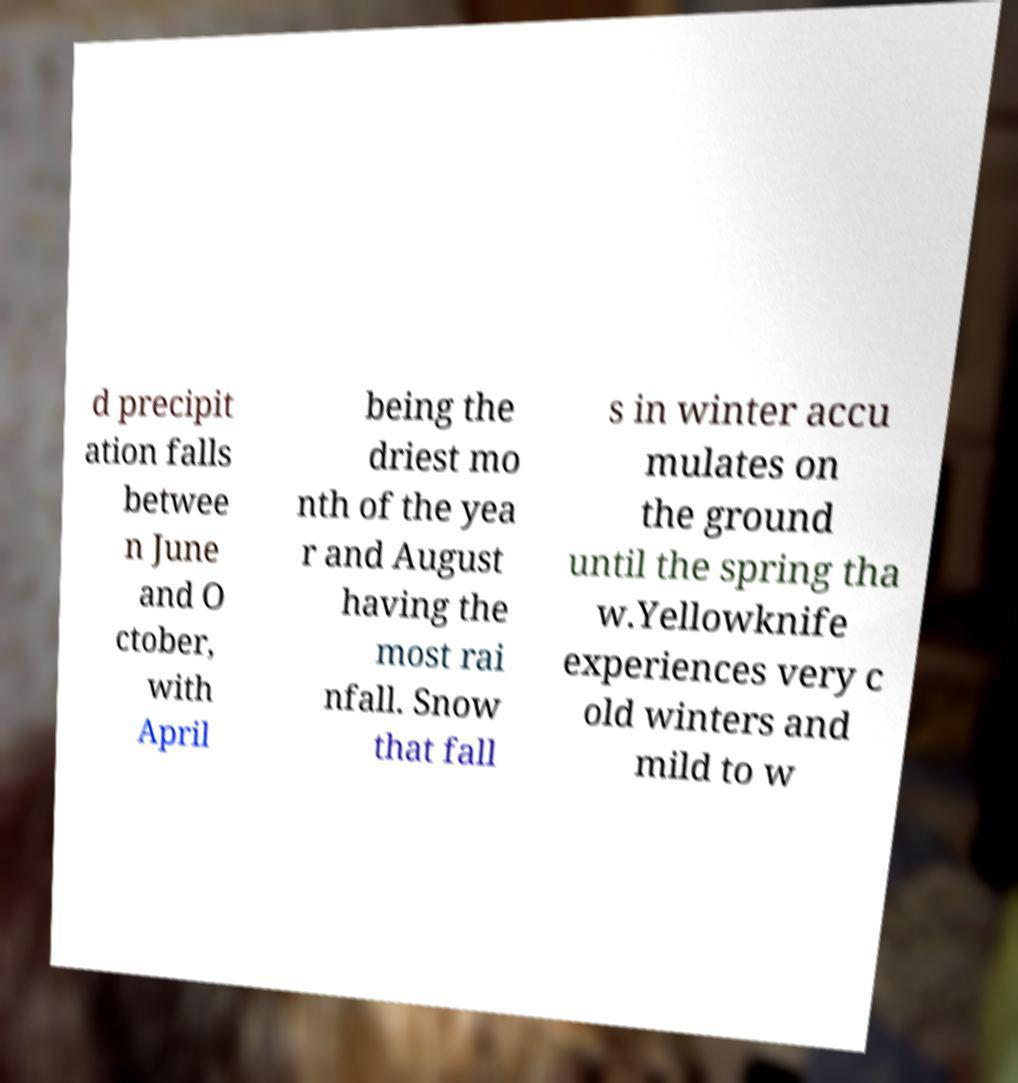Can you read and provide the text displayed in the image?This photo seems to have some interesting text. Can you extract and type it out for me? d precipit ation falls betwee n June and O ctober, with April being the driest mo nth of the yea r and August having the most rai nfall. Snow that fall s in winter accu mulates on the ground until the spring tha w.Yellowknife experiences very c old winters and mild to w 